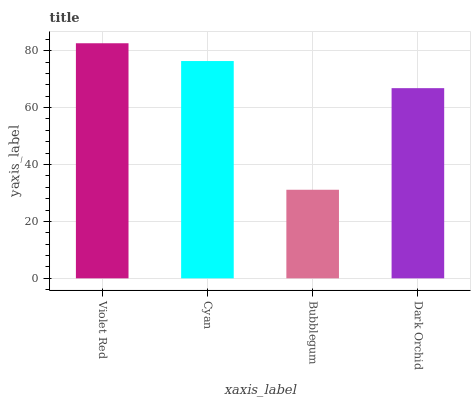Is Bubblegum the minimum?
Answer yes or no. Yes. Is Violet Red the maximum?
Answer yes or no. Yes. Is Cyan the minimum?
Answer yes or no. No. Is Cyan the maximum?
Answer yes or no. No. Is Violet Red greater than Cyan?
Answer yes or no. Yes. Is Cyan less than Violet Red?
Answer yes or no. Yes. Is Cyan greater than Violet Red?
Answer yes or no. No. Is Violet Red less than Cyan?
Answer yes or no. No. Is Cyan the high median?
Answer yes or no. Yes. Is Dark Orchid the low median?
Answer yes or no. Yes. Is Dark Orchid the high median?
Answer yes or no. No. Is Bubblegum the low median?
Answer yes or no. No. 